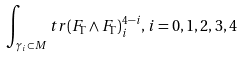<formula> <loc_0><loc_0><loc_500><loc_500>\int _ { \gamma _ { i } \subset M } t r ( F _ { \Gamma } \wedge F _ { \Gamma } ) _ { i } ^ { 4 - i } , \, i = 0 , 1 , 2 , 3 , 4</formula> 